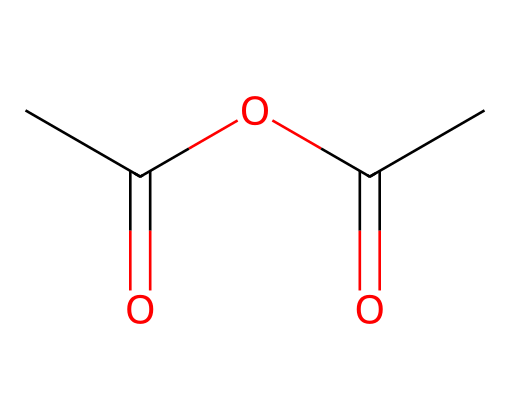How many carbon atoms are in acetic anhydride? The SMILES representation indicates that there are three carbon atoms (CC(=O)OC(=O)C). Each 'C' represents a carbon atom within the structure.
Answer: three What is the functional group present in acetic anhydride? In the SMILES notation, the presence of the 'C(=O)' indicates a carbonyl group. Since this structure contains two carbonyl groups, the functional group is anhydride.
Answer: anhydride What is the total number of oxygen atoms in acetic anhydride? The SMILES representation shows two 'O' symbols indicating two oxygen atoms, plus each carbonyl (C=O) brings in an additional oxygen. Therefore, there are four oxygen atoms total.
Answer: four Does acetic anhydride have polar or nonpolar characteristics? The presence of multiple electronegative oxygen atoms in the structure contributes to polar characteristics. The arrangement of carbonyl groups creates regions of partial charge, enhancing polarity.
Answer: polar What type of chemical reaction can acetic anhydride undergo? Acetic anhydride can participate in acylation reactions, which involve the addition of acyl groups to other compounds, especially in the production of esters or amides.
Answer: acylation Which type of chemical compound is acetic anhydride classified as? Based on its structure which contains two acyl groups derived from acetic acid, acetic anhydride is classified as an acid anhydride.
Answer: acid anhydride How many double bonds are present in acetic anhydride? In the SMILES representation, ‘(=O)’ indicates double bonds at the carbonyl groups. There are two such instances where double bonds occur, accounting for a total of two double bonds.
Answer: two 